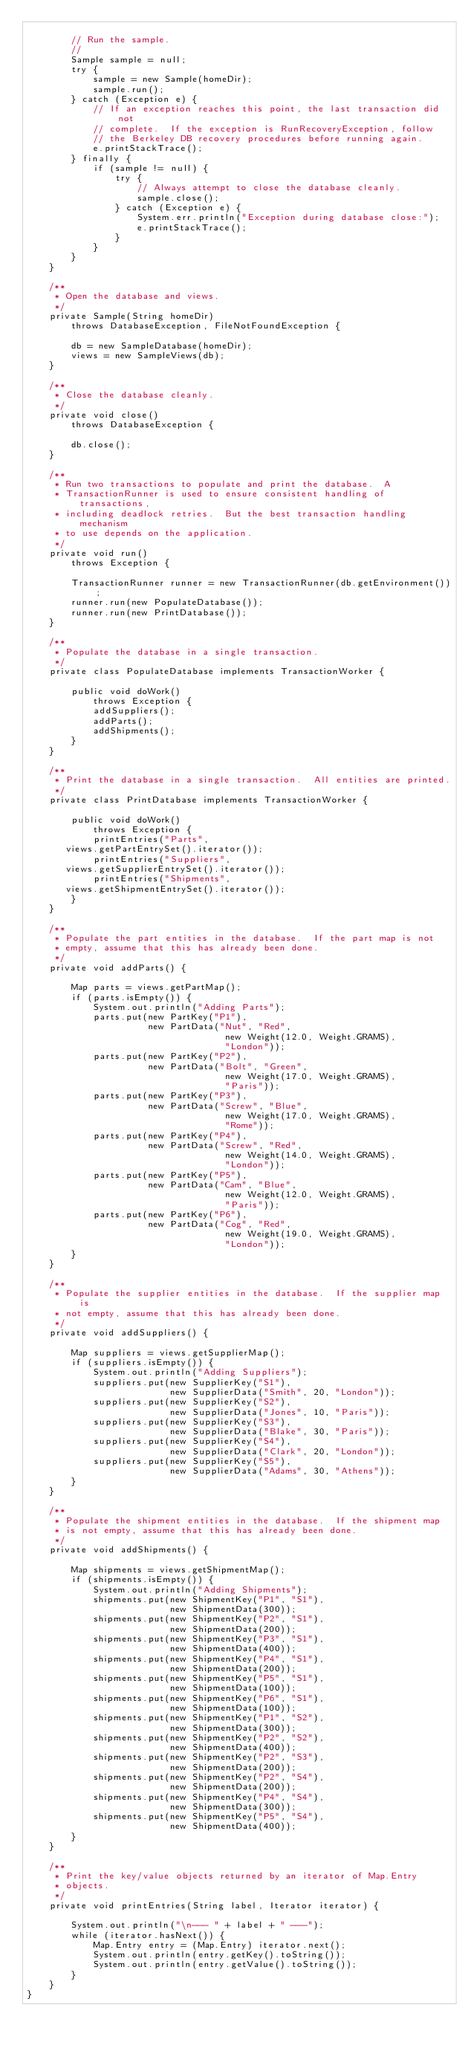Convert code to text. <code><loc_0><loc_0><loc_500><loc_500><_Java_>
        // Run the sample.
        //
        Sample sample = null;
        try {
            sample = new Sample(homeDir);
            sample.run();
        } catch (Exception e) {
            // If an exception reaches this point, the last transaction did not
            // complete.  If the exception is RunRecoveryException, follow
            // the Berkeley DB recovery procedures before running again.
            e.printStackTrace();
        } finally {
            if (sample != null) {
                try {
                    // Always attempt to close the database cleanly.
                    sample.close();
                } catch (Exception e) {
                    System.err.println("Exception during database close:");
                    e.printStackTrace();
                }
            }
        }
    }

    /**
     * Open the database and views.
     */
    private Sample(String homeDir)
        throws DatabaseException, FileNotFoundException {

        db = new SampleDatabase(homeDir);
        views = new SampleViews(db);
    }

    /**
     * Close the database cleanly.
     */
    private void close()
        throws DatabaseException {

        db.close();
    }

    /**
     * Run two transactions to populate and print the database.  A
     * TransactionRunner is used to ensure consistent handling of transactions,
     * including deadlock retries.  But the best transaction handling mechanism
     * to use depends on the application.
     */
    private void run()
        throws Exception {

        TransactionRunner runner = new TransactionRunner(db.getEnvironment());
        runner.run(new PopulateDatabase());
        runner.run(new PrintDatabase());
    }

    /**
     * Populate the database in a single transaction.
     */
    private class PopulateDatabase implements TransactionWorker {

        public void doWork()
            throws Exception {
            addSuppliers();
            addParts();
            addShipments();
        }
    }

    /**
     * Print the database in a single transaction.  All entities are printed.
     */
    private class PrintDatabase implements TransactionWorker {

        public void doWork()
            throws Exception {
            printEntries("Parts",
			 views.getPartEntrySet().iterator());
            printEntries("Suppliers",
			 views.getSupplierEntrySet().iterator());
            printEntries("Shipments",
			 views.getShipmentEntrySet().iterator());
        }
    }

    /**
     * Populate the part entities in the database.  If the part map is not
     * empty, assume that this has already been done.
     */
    private void addParts() {

        Map parts = views.getPartMap();
        if (parts.isEmpty()) {
            System.out.println("Adding Parts");
            parts.put(new PartKey("P1"),
                      new PartData("Nut", "Red",
                                    new Weight(12.0, Weight.GRAMS),
                                    "London"));
            parts.put(new PartKey("P2"),
                      new PartData("Bolt", "Green",
                                    new Weight(17.0, Weight.GRAMS),
                                    "Paris"));
            parts.put(new PartKey("P3"),
                      new PartData("Screw", "Blue",
                                    new Weight(17.0, Weight.GRAMS),
                                    "Rome"));
            parts.put(new PartKey("P4"),
                      new PartData("Screw", "Red",
                                    new Weight(14.0, Weight.GRAMS),
                                    "London"));
            parts.put(new PartKey("P5"),
                      new PartData("Cam", "Blue",
                                    new Weight(12.0, Weight.GRAMS),
                                    "Paris"));
            parts.put(new PartKey("P6"),
                      new PartData("Cog", "Red",
                                    new Weight(19.0, Weight.GRAMS),
                                    "London"));
        }
    }

    /**
     * Populate the supplier entities in the database.  If the supplier map is
     * not empty, assume that this has already been done.
     */
    private void addSuppliers() {

        Map suppliers = views.getSupplierMap();
        if (suppliers.isEmpty()) {
            System.out.println("Adding Suppliers");
            suppliers.put(new SupplierKey("S1"),
                          new SupplierData("Smith", 20, "London"));
            suppliers.put(new SupplierKey("S2"),
                          new SupplierData("Jones", 10, "Paris"));
            suppliers.put(new SupplierKey("S3"),
                          new SupplierData("Blake", 30, "Paris"));
            suppliers.put(new SupplierKey("S4"),
                          new SupplierData("Clark", 20, "London"));
            suppliers.put(new SupplierKey("S5"),
                          new SupplierData("Adams", 30, "Athens"));
        }
    }

    /**
     * Populate the shipment entities in the database.  If the shipment map
     * is not empty, assume that this has already been done.
     */
    private void addShipments() {

        Map shipments = views.getShipmentMap();
        if (shipments.isEmpty()) {
            System.out.println("Adding Shipments");
            shipments.put(new ShipmentKey("P1", "S1"),
                          new ShipmentData(300));
            shipments.put(new ShipmentKey("P2", "S1"),
                          new ShipmentData(200));
            shipments.put(new ShipmentKey("P3", "S1"),
                          new ShipmentData(400));
            shipments.put(new ShipmentKey("P4", "S1"),
                          new ShipmentData(200));
            shipments.put(new ShipmentKey("P5", "S1"),
                          new ShipmentData(100));
            shipments.put(new ShipmentKey("P6", "S1"),
                          new ShipmentData(100));
            shipments.put(new ShipmentKey("P1", "S2"),
                          new ShipmentData(300));
            shipments.put(new ShipmentKey("P2", "S2"),
                          new ShipmentData(400));
            shipments.put(new ShipmentKey("P2", "S3"),
                          new ShipmentData(200));
            shipments.put(new ShipmentKey("P2", "S4"),
                          new ShipmentData(200));
            shipments.put(new ShipmentKey("P4", "S4"),
                          new ShipmentData(300));
            shipments.put(new ShipmentKey("P5", "S4"),
                          new ShipmentData(400));
        }
    }

    /**
     * Print the key/value objects returned by an iterator of Map.Entry
     * objects.
     */
    private void printEntries(String label, Iterator iterator) {

        System.out.println("\n--- " + label + " ---");
        while (iterator.hasNext()) {
            Map.Entry entry = (Map.Entry) iterator.next();
            System.out.println(entry.getKey().toString());
            System.out.println(entry.getValue().toString());
        }
    }
}
</code> 